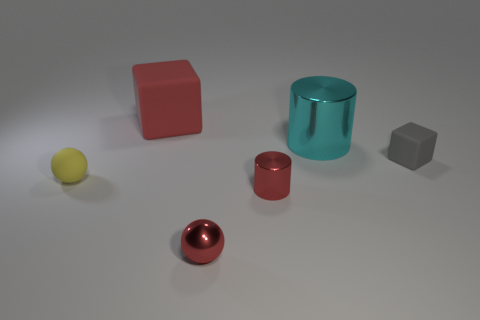Add 1 matte spheres. How many objects exist? 7 Subtract all spheres. How many objects are left? 4 Add 6 big cyan matte cubes. How many big cyan matte cubes exist? 6 Subtract 0 purple balls. How many objects are left? 6 Subtract all large cylinders. Subtract all gray blocks. How many objects are left? 4 Add 2 yellow rubber things. How many yellow rubber things are left? 3 